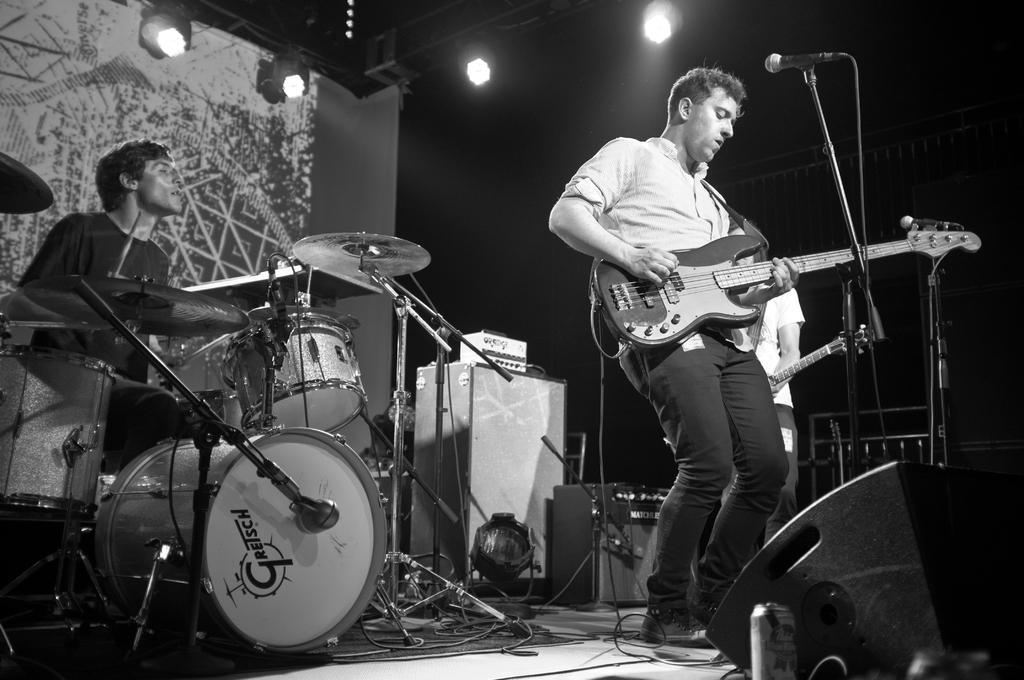Can you describe this image briefly? This picture shows two men playing guitar holding in hands and we see a microphone and we see a man seated and playing drums and we see few lights on the top 